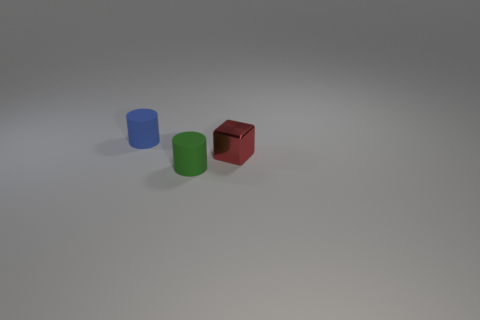There is another object that is the same shape as the blue matte object; what is it made of?
Your answer should be compact. Rubber. What number of metal things are either small blocks or tiny gray spheres?
Give a very brief answer. 1. There is a tiny blue object that is the same material as the green thing; what is its shape?
Your response must be concise. Cylinder. How many other small green objects are the same shape as the green rubber thing?
Give a very brief answer. 0. Is the shape of the blue rubber thing left of the tiny red shiny object the same as the thing that is in front of the tiny block?
Keep it short and to the point. Yes. How many things are cylinders or small objects to the right of the blue matte thing?
Ensure brevity in your answer.  3. What number of purple spheres are the same size as the blue rubber cylinder?
Your response must be concise. 0. What number of yellow objects are tiny objects or rubber cylinders?
Provide a succinct answer. 0. There is a rubber thing right of the blue object left of the small green rubber object; what is its shape?
Give a very brief answer. Cylinder. What is the shape of the red shiny thing that is the same size as the green thing?
Ensure brevity in your answer.  Cube. 